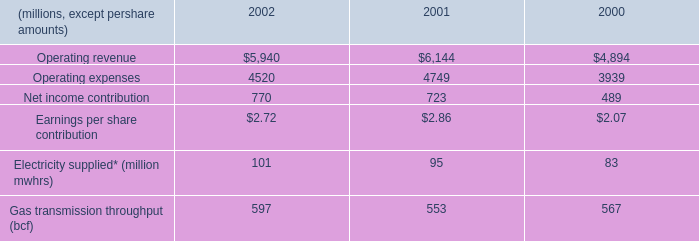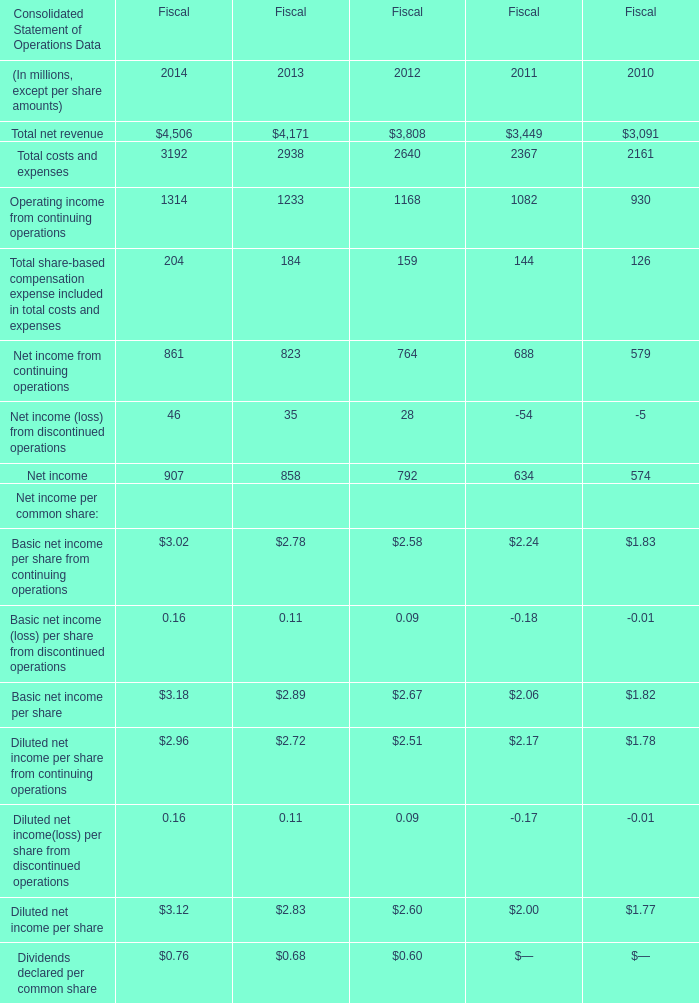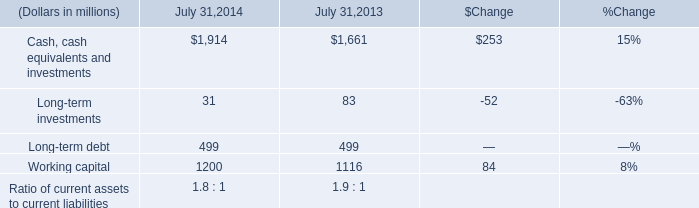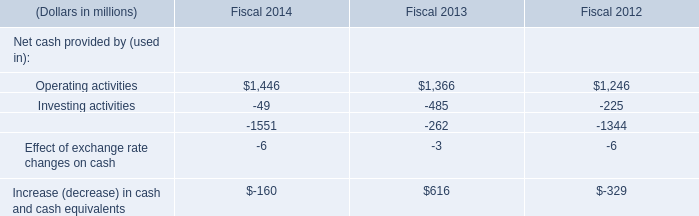what is the growth rate in operating revenue from 2001 to 2002? 
Computations: ((5940 - 6144) / 6144)
Answer: -0.0332. 